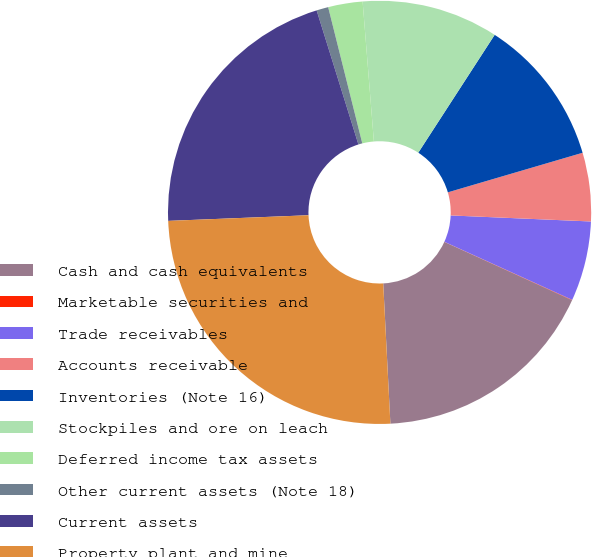Convert chart to OTSL. <chart><loc_0><loc_0><loc_500><loc_500><pie_chart><fcel>Cash and cash equivalents<fcel>Marketable securities and<fcel>Trade receivables<fcel>Accounts receivable<fcel>Inventories (Note 16)<fcel>Stockpiles and ore on leach<fcel>Deferred income tax assets<fcel>Other current assets (Note 18)<fcel>Current assets<fcel>Property plant and mine<nl><fcel>17.37%<fcel>0.03%<fcel>6.1%<fcel>5.23%<fcel>11.3%<fcel>10.43%<fcel>2.63%<fcel>0.9%<fcel>20.83%<fcel>25.17%<nl></chart> 